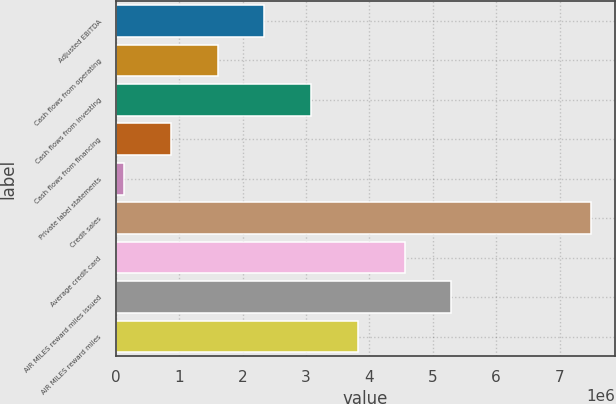<chart> <loc_0><loc_0><loc_500><loc_500><bar_chart><fcel>Adjusted EBITDA<fcel>Cash flows from operating<fcel>Cash flows from investing<fcel>Cash flows from financing<fcel>Private label statements<fcel>Credit sales<fcel>Average credit card<fcel>AIR MILES reward miles issued<fcel>AIR MILES reward miles<nl><fcel>2.34557e+06<fcel>1.6088e+06<fcel>3.08234e+06<fcel>872030<fcel>135261<fcel>7.50295e+06<fcel>4.55587e+06<fcel>5.29264e+06<fcel>3.8191e+06<nl></chart> 